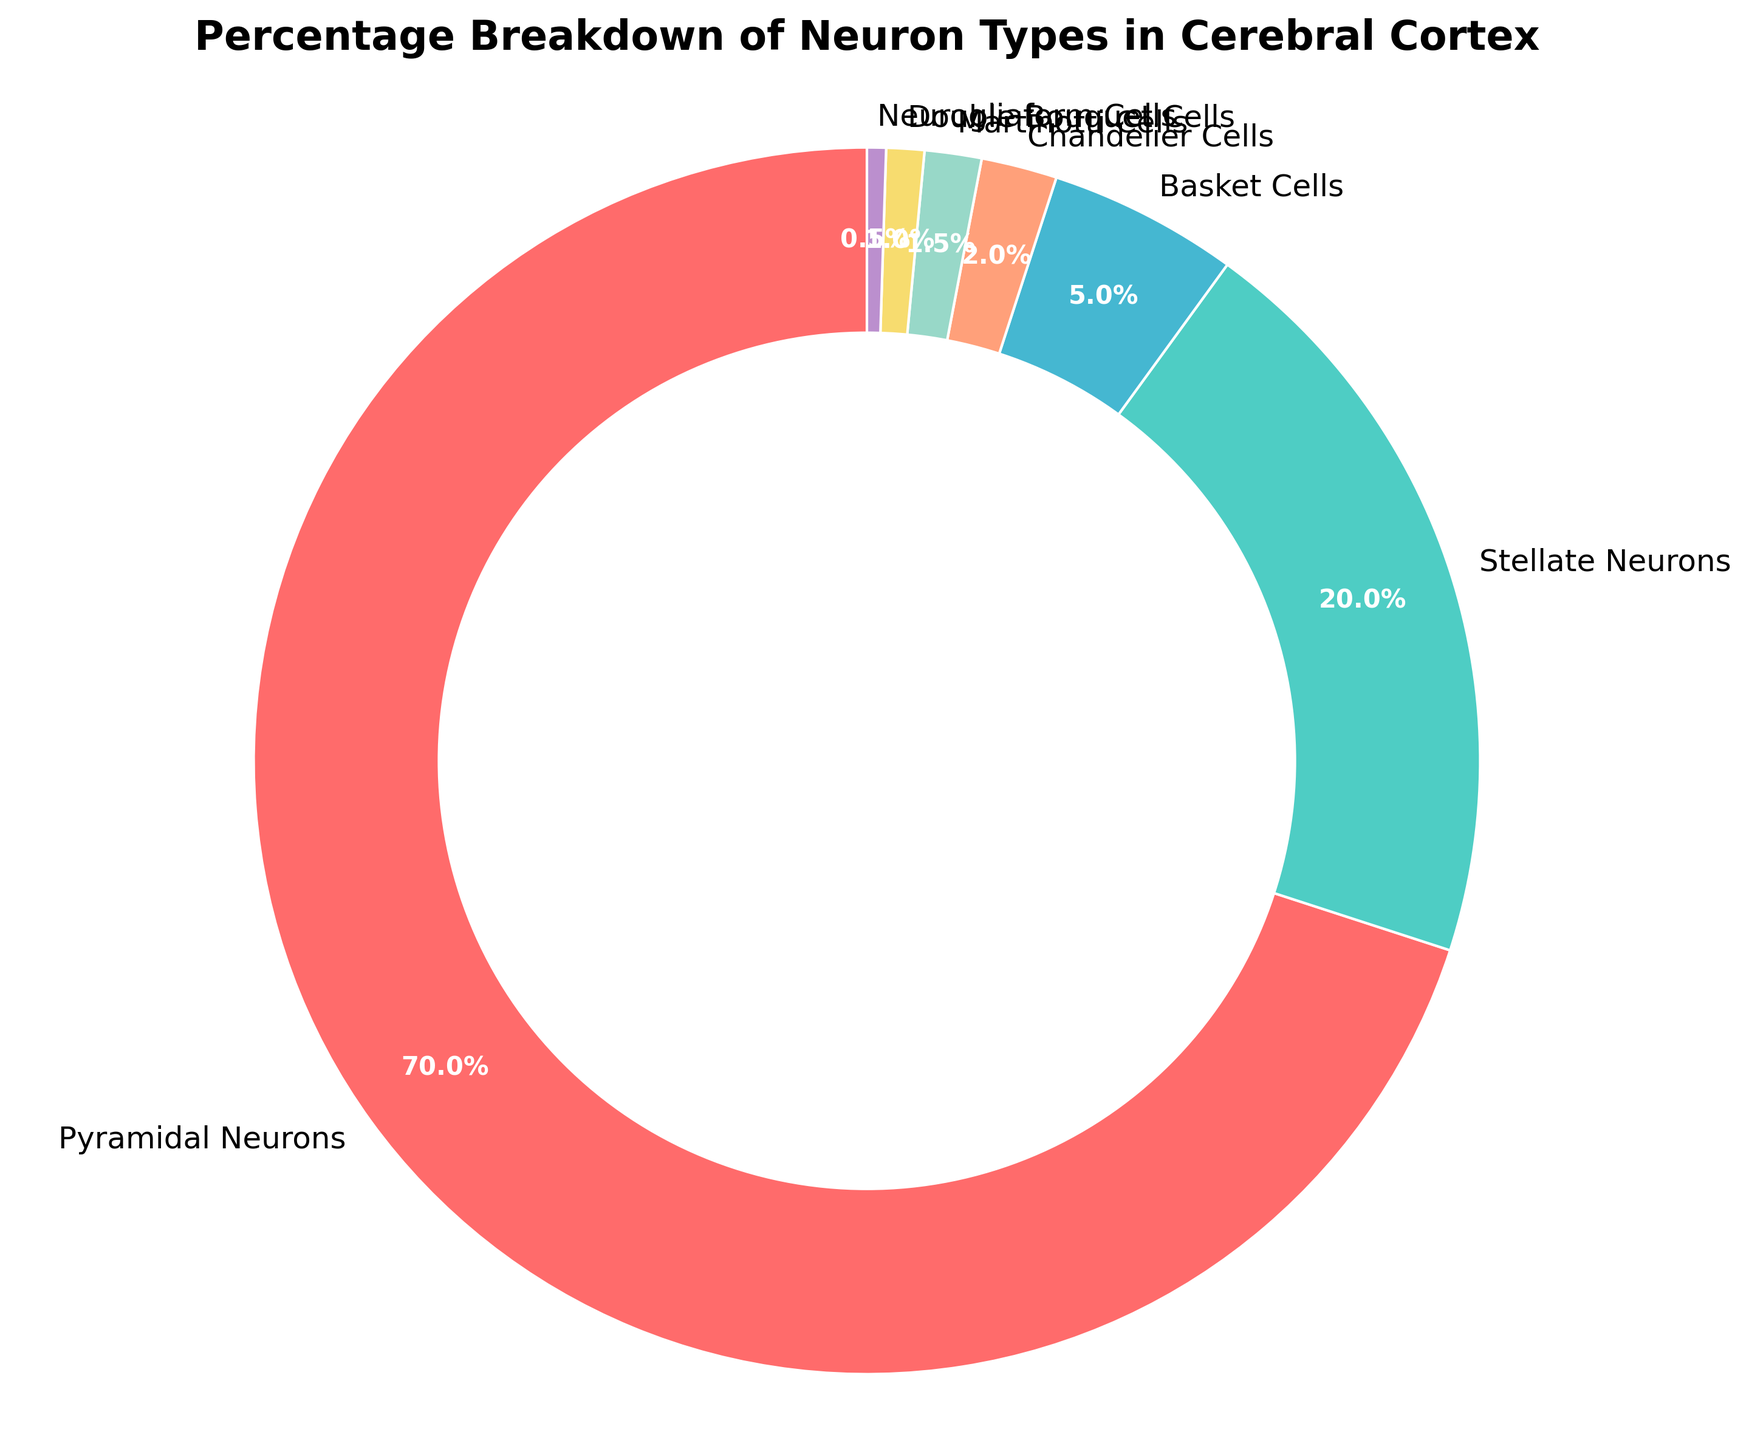Which neuron type is the most common in the cerebral cortex? The pie chart shows that Pyramidal Neurons have the largest section, making them the most common type.
Answer: Pyramidal Neurons Which neuron type occupies the smallest percentage in the cerebral cortex? The smallest section of the pie chart belongs to Neurogliaform Cells, indicating they are the least common.
Answer: Neurogliaform Cells What is the combined percentage of Stellate Neurons and Basket Cells? The percentages for Stellate Neurons and Basket Cells are 20% and 5%, respectively. Adding them gives 20% + 5% = 25%.
Answer: 25% Are there more Martinotti Cells or Double Bouquet Cells in the cerebral cortex? The pie chart shows that Martinotti Cells occupy 1.5%, while Double Bouquet Cells take up 1%. Therefore, there are more Martinotti Cells.
Answer: Martinotti Cells What is the difference in percentage between Pyramidal Neurons and Stellate Neurons? Pyramidal Neurons have 70%, and Stellate Neurons have 20%. The difference is 70% - 20% = 50%.
Answer: 50% Which two neuron types combined make up exactly 3% of the cerebral cortex’s neurons? The chart shows that Chandelier Cells are 2% and Neurogliaform Cells are 0.5%, making their sum 2% + 0.5% = 2.5%. The actual correct answer is Martinotti Cells (1.5%) and Double Bouquet Cells (1%) combined make 1.5% + 1% = 2.5%.
Answer: Martinotti Cells and Double Bouquet Cells Does the proportion of Basket Cells exceed that of Chandelier Cells? The chart shows Basket Cells occupy 5%, while Chandelier Cells take up 2%, so Basket Cells have a higher proportion.
Answer: Yes What's the total percentage of neuron types that each has less than 2% share? The neuron types with less than 2% are Chandelier Cells (2%), Martinotti Cells (1.5%), Double Bouquet Cells (1%), and Neurogliaform Cells (0.5%). Adding these gives 2% + 1.5% + 1% + 0.5% = 5%.
Answer: 5% What color represents Stellate Neurons, and do any other neuron types share this color? Stellate Neurons are represented by green, and no other neuron types share this color in the pie chart.
Answer: Green, No 